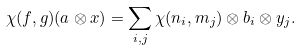<formula> <loc_0><loc_0><loc_500><loc_500>\chi ( f , g ) ( a \otimes x ) = \sum _ { i , j } \chi ( n _ { i } , m _ { j } ) \otimes b _ { i } \otimes y _ { j } .</formula> 